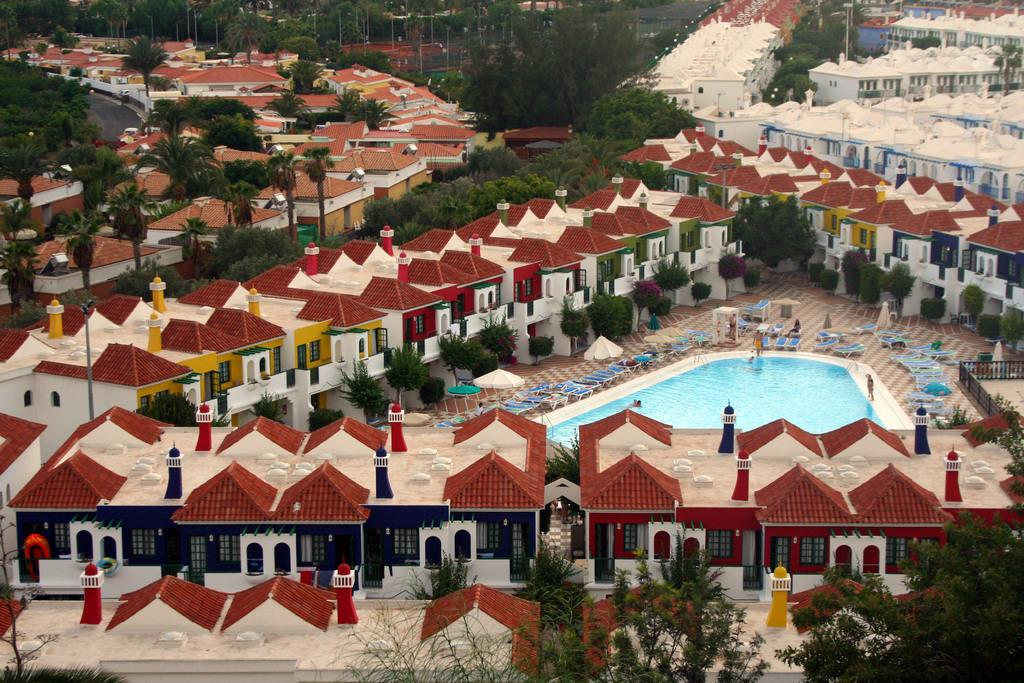What type of structures can be seen in the image? There are many buildings in the image. What else can be seen in the image besides buildings? There are trees, a swimming pool, parasols, and chairs visible in the image. Where is the swimming pool located in the image? The swimming pool is in the center of the image. What might provide shade for people in the image? Parasols are visible in the image, which could provide shade. What type of apparatus is used for cleaning teeth in the image? There is no apparatus for cleaning teeth present in the image. What selection of toothbrushes can be seen in the image? There is no selection of toothbrushes present in the image. 